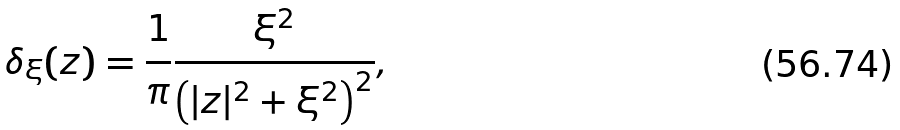<formula> <loc_0><loc_0><loc_500><loc_500>\delta _ { \xi } ( z ) = \frac { 1 } { \pi } \frac { \xi ^ { 2 } } { \left ( | z | ^ { 2 } + \xi ^ { 2 } \right ) ^ { 2 } } ,</formula> 